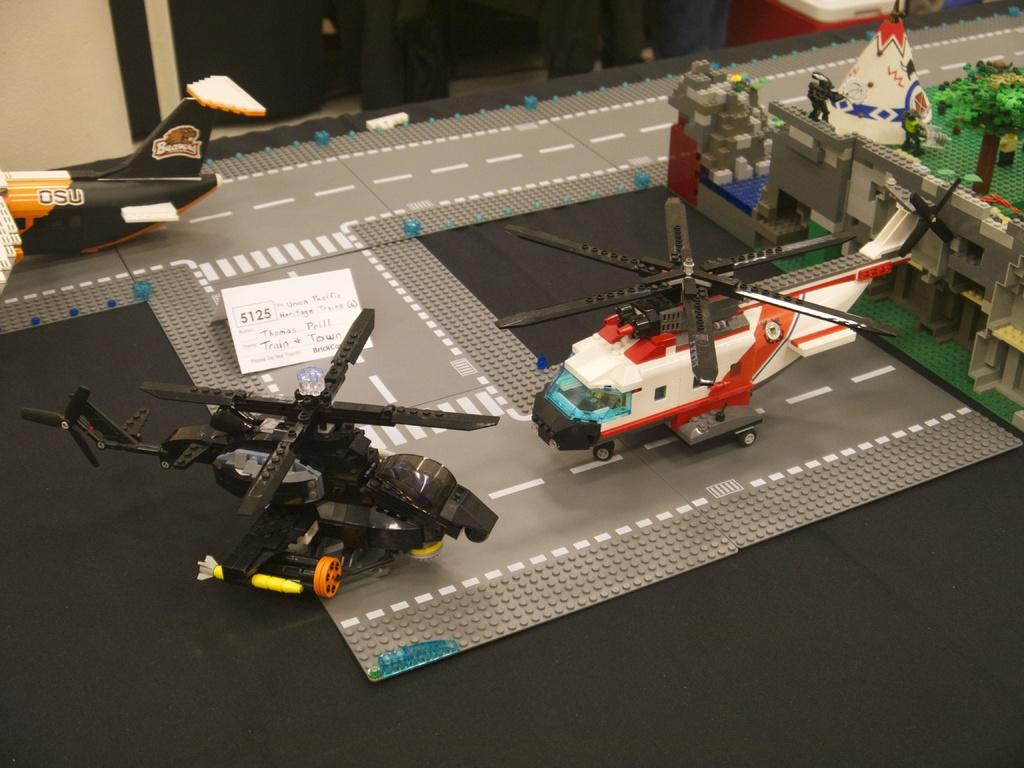What objects can be seen in the image? There are toys in the image. What is the color of the surface the toys are on? The surface the toys are on is black in color. Can you see any crayons being used to draw on the black surface in the image? There is no mention of crayons or drawing in the image, so we cannot determine if any crayons are present or being used. 